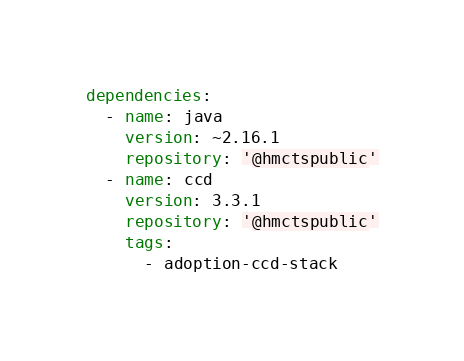Convert code to text. <code><loc_0><loc_0><loc_500><loc_500><_YAML_>dependencies:
  - name: java
    version: ~2.16.1
    repository: '@hmctspublic'
  - name: ccd
    version: 3.3.1
    repository: '@hmctspublic'
    tags:
      - adoption-ccd-stack
</code> 